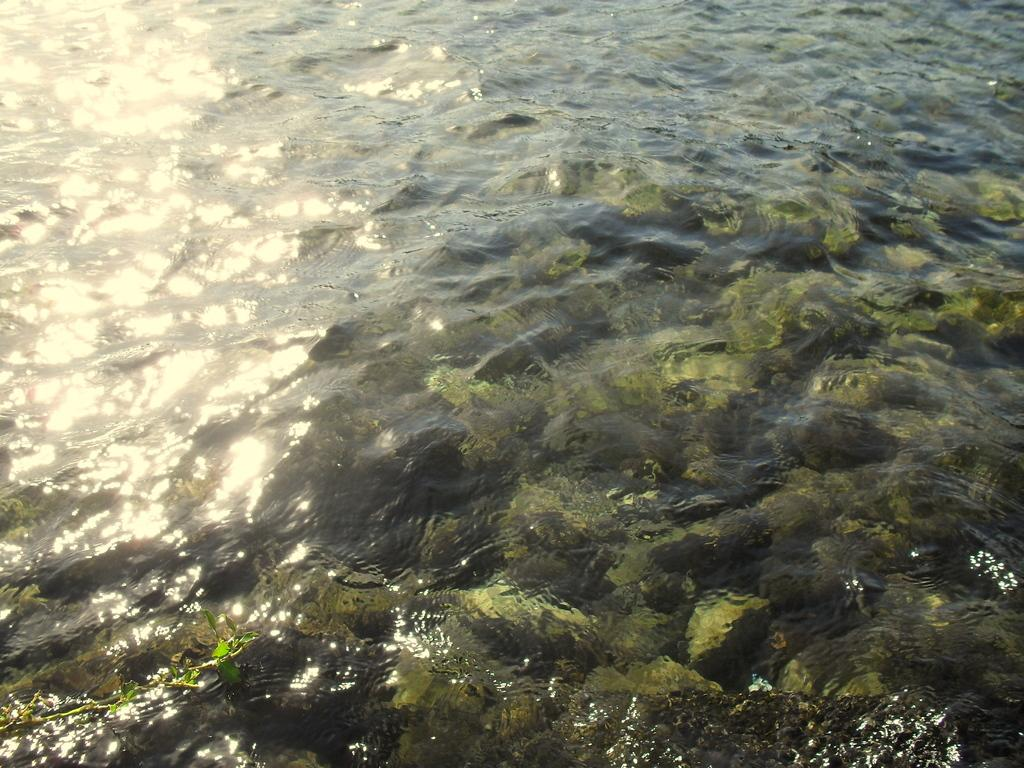What is visible in the image? Water is visible in the image. What can be found in the water? There are green color objects in the water. What type of noise can be heard coming from the sidewalk in the image? There is no sidewalk present in the image, so it is not possible to determine what, if any, noise might be heard. 